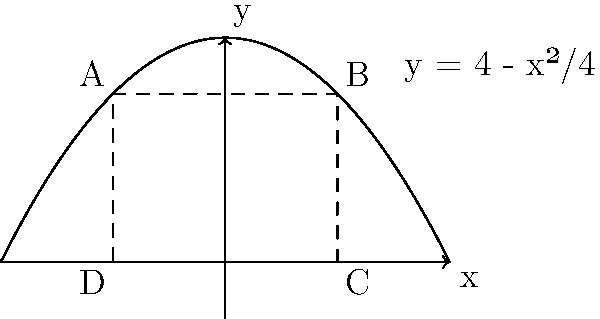As an educator passionate about innovative teaching methods, you want to create a challenging calculus problem for your advanced students. Consider a parabola with the equation $y = 4 - \frac{x^2}{4}$. A rectangle is inscribed in this parabola with its base on the x-axis, as shown in the figure. What are the dimensions of the rectangle that will maximize its area? Provide your answer in terms of width and height. Let's approach this step-by-step:

1) Let the width of the rectangle be $2x$ (from $-x$ to $x$ on the x-axis) and its height be $y$.

2) The area of the rectangle is $A = 2xy$.

3) We need to express $y$ in terms of $x$ using the equation of the parabola:
   $y = 4 - \frac{x^2}{4}$

4) Now, we can express the area as a function of $x$:
   $A(x) = 2x(4 - \frac{x^2}{4}) = 8x - \frac{x^3}{2}$

5) To find the maximum area, we need to find where $\frac{dA}{dx} = 0$:
   $\frac{dA}{dx} = 8 - \frac{3x^2}{2} = 0$

6) Solving this equation:
   $8 - \frac{3x^2}{2} = 0$
   $\frac{3x^2}{2} = 8$
   $x^2 = \frac{16}{3}$
   $x = \pm \frac{4}{\sqrt{3}}$

7) Since we're dealing with width, we take the positive value:
   $x = \frac{4}{\sqrt{3}}$

8) The width of the rectangle is $2x = \frac{8}{\sqrt{3}}$

9) To find the height, we substitute this $x$ value into the parabola equation:
   $y = 4 - \frac{(\frac{4}{\sqrt{3}})^2}{4} = 4 - \frac{16}{12} = \frac{8}{3}$

Therefore, the dimensions that maximize the area are:
Width = $\frac{8}{\sqrt{3}}$, Height = $\frac{8}{3}$
Answer: Width = $\frac{8}{\sqrt{3}}$, Height = $\frac{8}{3}$ 